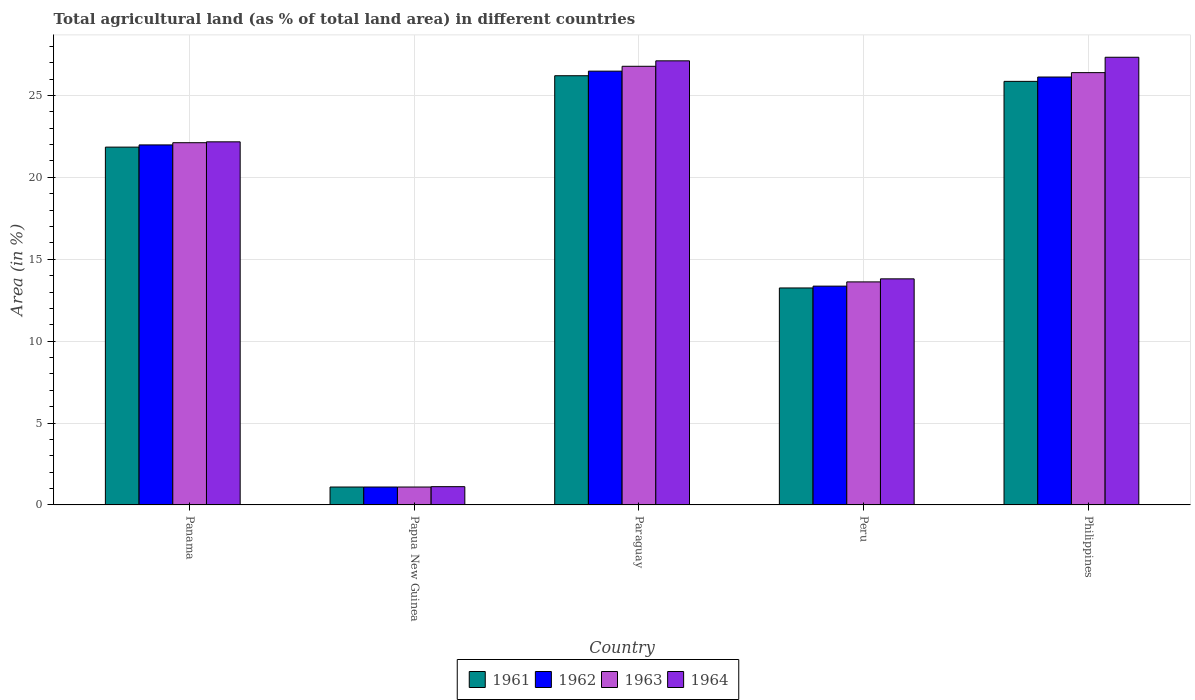How many different coloured bars are there?
Offer a terse response. 4. How many groups of bars are there?
Keep it short and to the point. 5. Are the number of bars per tick equal to the number of legend labels?
Your answer should be compact. Yes. Are the number of bars on each tick of the X-axis equal?
Offer a very short reply. Yes. How many bars are there on the 5th tick from the right?
Ensure brevity in your answer.  4. What is the label of the 5th group of bars from the left?
Your response must be concise. Philippines. In how many cases, is the number of bars for a given country not equal to the number of legend labels?
Offer a terse response. 0. What is the percentage of agricultural land in 1961 in Philippines?
Make the answer very short. 25.86. Across all countries, what is the maximum percentage of agricultural land in 1961?
Ensure brevity in your answer.  26.2. Across all countries, what is the minimum percentage of agricultural land in 1962?
Give a very brief answer. 1.09. In which country was the percentage of agricultural land in 1964 maximum?
Keep it short and to the point. Philippines. In which country was the percentage of agricultural land in 1963 minimum?
Provide a succinct answer. Papua New Guinea. What is the total percentage of agricultural land in 1962 in the graph?
Your answer should be compact. 89.04. What is the difference between the percentage of agricultural land in 1964 in Paraguay and that in Peru?
Ensure brevity in your answer.  13.31. What is the difference between the percentage of agricultural land in 1964 in Paraguay and the percentage of agricultural land in 1962 in Panama?
Your answer should be very brief. 5.13. What is the average percentage of agricultural land in 1964 per country?
Give a very brief answer. 18.31. What is the difference between the percentage of agricultural land of/in 1961 and percentage of agricultural land of/in 1963 in Peru?
Provide a short and direct response. -0.37. In how many countries, is the percentage of agricultural land in 1962 greater than 12 %?
Ensure brevity in your answer.  4. What is the ratio of the percentage of agricultural land in 1963 in Papua New Guinea to that in Paraguay?
Make the answer very short. 0.04. Is the difference between the percentage of agricultural land in 1961 in Panama and Philippines greater than the difference between the percentage of agricultural land in 1963 in Panama and Philippines?
Your answer should be compact. Yes. What is the difference between the highest and the second highest percentage of agricultural land in 1962?
Your answer should be very brief. 0.36. What is the difference between the highest and the lowest percentage of agricultural land in 1961?
Keep it short and to the point. 25.11. In how many countries, is the percentage of agricultural land in 1961 greater than the average percentage of agricultural land in 1961 taken over all countries?
Offer a terse response. 3. Is the sum of the percentage of agricultural land in 1964 in Paraguay and Peru greater than the maximum percentage of agricultural land in 1962 across all countries?
Your response must be concise. Yes. What does the 3rd bar from the left in Philippines represents?
Provide a short and direct response. 1963. What does the 3rd bar from the right in Paraguay represents?
Give a very brief answer. 1962. Are all the bars in the graph horizontal?
Your answer should be compact. No. How many countries are there in the graph?
Ensure brevity in your answer.  5. What is the difference between two consecutive major ticks on the Y-axis?
Your response must be concise. 5. Are the values on the major ticks of Y-axis written in scientific E-notation?
Your response must be concise. No. Does the graph contain any zero values?
Your answer should be very brief. No. What is the title of the graph?
Make the answer very short. Total agricultural land (as % of total land area) in different countries. What is the label or title of the X-axis?
Ensure brevity in your answer.  Country. What is the label or title of the Y-axis?
Your response must be concise. Area (in %). What is the Area (in %) in 1961 in Panama?
Your answer should be compact. 21.85. What is the Area (in %) in 1962 in Panama?
Provide a succinct answer. 21.98. What is the Area (in %) of 1963 in Panama?
Ensure brevity in your answer.  22.11. What is the Area (in %) of 1964 in Panama?
Provide a succinct answer. 22.17. What is the Area (in %) in 1961 in Papua New Guinea?
Your answer should be compact. 1.09. What is the Area (in %) of 1962 in Papua New Guinea?
Provide a succinct answer. 1.09. What is the Area (in %) in 1963 in Papua New Guinea?
Your response must be concise. 1.09. What is the Area (in %) of 1964 in Papua New Guinea?
Your answer should be compact. 1.12. What is the Area (in %) in 1961 in Paraguay?
Your answer should be very brief. 26.2. What is the Area (in %) in 1962 in Paraguay?
Your answer should be very brief. 26.48. What is the Area (in %) in 1963 in Paraguay?
Offer a terse response. 26.78. What is the Area (in %) of 1964 in Paraguay?
Provide a succinct answer. 27.11. What is the Area (in %) in 1961 in Peru?
Your response must be concise. 13.25. What is the Area (in %) in 1962 in Peru?
Keep it short and to the point. 13.36. What is the Area (in %) in 1963 in Peru?
Provide a succinct answer. 13.62. What is the Area (in %) in 1964 in Peru?
Offer a terse response. 13.8. What is the Area (in %) of 1961 in Philippines?
Your response must be concise. 25.86. What is the Area (in %) in 1962 in Philippines?
Offer a terse response. 26.12. What is the Area (in %) of 1963 in Philippines?
Provide a succinct answer. 26.39. What is the Area (in %) in 1964 in Philippines?
Keep it short and to the point. 27.33. Across all countries, what is the maximum Area (in %) of 1961?
Provide a short and direct response. 26.2. Across all countries, what is the maximum Area (in %) in 1962?
Provide a short and direct response. 26.48. Across all countries, what is the maximum Area (in %) of 1963?
Your answer should be compact. 26.78. Across all countries, what is the maximum Area (in %) in 1964?
Make the answer very short. 27.33. Across all countries, what is the minimum Area (in %) of 1961?
Provide a short and direct response. 1.09. Across all countries, what is the minimum Area (in %) of 1962?
Ensure brevity in your answer.  1.09. Across all countries, what is the minimum Area (in %) of 1963?
Ensure brevity in your answer.  1.09. Across all countries, what is the minimum Area (in %) of 1964?
Offer a very short reply. 1.12. What is the total Area (in %) in 1961 in the graph?
Your answer should be compact. 88.25. What is the total Area (in %) in 1962 in the graph?
Keep it short and to the point. 89.04. What is the total Area (in %) in 1963 in the graph?
Provide a short and direct response. 90. What is the total Area (in %) of 1964 in the graph?
Provide a succinct answer. 91.53. What is the difference between the Area (in %) in 1961 in Panama and that in Papua New Guinea?
Provide a short and direct response. 20.75. What is the difference between the Area (in %) in 1962 in Panama and that in Papua New Guinea?
Your response must be concise. 20.89. What is the difference between the Area (in %) in 1963 in Panama and that in Papua New Guinea?
Ensure brevity in your answer.  21.02. What is the difference between the Area (in %) of 1964 in Panama and that in Papua New Guinea?
Your answer should be compact. 21.05. What is the difference between the Area (in %) in 1961 in Panama and that in Paraguay?
Provide a short and direct response. -4.36. What is the difference between the Area (in %) in 1962 in Panama and that in Paraguay?
Offer a very short reply. -4.5. What is the difference between the Area (in %) in 1963 in Panama and that in Paraguay?
Provide a short and direct response. -4.67. What is the difference between the Area (in %) of 1964 in Panama and that in Paraguay?
Your response must be concise. -4.94. What is the difference between the Area (in %) in 1961 in Panama and that in Peru?
Offer a terse response. 8.6. What is the difference between the Area (in %) in 1962 in Panama and that in Peru?
Your answer should be compact. 8.62. What is the difference between the Area (in %) of 1963 in Panama and that in Peru?
Provide a succinct answer. 8.5. What is the difference between the Area (in %) of 1964 in Panama and that in Peru?
Provide a short and direct response. 8.37. What is the difference between the Area (in %) of 1961 in Panama and that in Philippines?
Provide a succinct answer. -4.01. What is the difference between the Area (in %) in 1962 in Panama and that in Philippines?
Offer a terse response. -4.14. What is the difference between the Area (in %) of 1963 in Panama and that in Philippines?
Provide a short and direct response. -4.28. What is the difference between the Area (in %) of 1964 in Panama and that in Philippines?
Provide a short and direct response. -5.16. What is the difference between the Area (in %) in 1961 in Papua New Guinea and that in Paraguay?
Your answer should be compact. -25.11. What is the difference between the Area (in %) in 1962 in Papua New Guinea and that in Paraguay?
Ensure brevity in your answer.  -25.39. What is the difference between the Area (in %) of 1963 in Papua New Guinea and that in Paraguay?
Offer a very short reply. -25.69. What is the difference between the Area (in %) of 1964 in Papua New Guinea and that in Paraguay?
Ensure brevity in your answer.  -26. What is the difference between the Area (in %) in 1961 in Papua New Guinea and that in Peru?
Provide a short and direct response. -12.15. What is the difference between the Area (in %) in 1962 in Papua New Guinea and that in Peru?
Provide a succinct answer. -12.27. What is the difference between the Area (in %) of 1963 in Papua New Guinea and that in Peru?
Make the answer very short. -12.52. What is the difference between the Area (in %) of 1964 in Papua New Guinea and that in Peru?
Offer a terse response. -12.69. What is the difference between the Area (in %) in 1961 in Papua New Guinea and that in Philippines?
Your answer should be very brief. -24.77. What is the difference between the Area (in %) in 1962 in Papua New Guinea and that in Philippines?
Provide a succinct answer. -25.03. What is the difference between the Area (in %) in 1963 in Papua New Guinea and that in Philippines?
Your answer should be very brief. -25.3. What is the difference between the Area (in %) in 1964 in Papua New Guinea and that in Philippines?
Your answer should be compact. -26.22. What is the difference between the Area (in %) in 1961 in Paraguay and that in Peru?
Your response must be concise. 12.96. What is the difference between the Area (in %) in 1962 in Paraguay and that in Peru?
Your answer should be very brief. 13.13. What is the difference between the Area (in %) of 1963 in Paraguay and that in Peru?
Offer a terse response. 13.16. What is the difference between the Area (in %) in 1964 in Paraguay and that in Peru?
Provide a short and direct response. 13.31. What is the difference between the Area (in %) in 1961 in Paraguay and that in Philippines?
Offer a very short reply. 0.34. What is the difference between the Area (in %) in 1962 in Paraguay and that in Philippines?
Offer a terse response. 0.36. What is the difference between the Area (in %) of 1963 in Paraguay and that in Philippines?
Your answer should be very brief. 0.39. What is the difference between the Area (in %) of 1964 in Paraguay and that in Philippines?
Offer a very short reply. -0.22. What is the difference between the Area (in %) of 1961 in Peru and that in Philippines?
Offer a very short reply. -12.61. What is the difference between the Area (in %) in 1962 in Peru and that in Philippines?
Offer a very short reply. -12.77. What is the difference between the Area (in %) in 1963 in Peru and that in Philippines?
Ensure brevity in your answer.  -12.78. What is the difference between the Area (in %) in 1964 in Peru and that in Philippines?
Your answer should be compact. -13.53. What is the difference between the Area (in %) of 1961 in Panama and the Area (in %) of 1962 in Papua New Guinea?
Offer a terse response. 20.75. What is the difference between the Area (in %) in 1961 in Panama and the Area (in %) in 1963 in Papua New Guinea?
Your response must be concise. 20.75. What is the difference between the Area (in %) of 1961 in Panama and the Area (in %) of 1964 in Papua New Guinea?
Offer a very short reply. 20.73. What is the difference between the Area (in %) in 1962 in Panama and the Area (in %) in 1963 in Papua New Guinea?
Make the answer very short. 20.89. What is the difference between the Area (in %) in 1962 in Panama and the Area (in %) in 1964 in Papua New Guinea?
Offer a very short reply. 20.86. What is the difference between the Area (in %) of 1963 in Panama and the Area (in %) of 1964 in Papua New Guinea?
Make the answer very short. 21. What is the difference between the Area (in %) in 1961 in Panama and the Area (in %) in 1962 in Paraguay?
Your answer should be compact. -4.64. What is the difference between the Area (in %) of 1961 in Panama and the Area (in %) of 1963 in Paraguay?
Give a very brief answer. -4.94. What is the difference between the Area (in %) in 1961 in Panama and the Area (in %) in 1964 in Paraguay?
Provide a succinct answer. -5.27. What is the difference between the Area (in %) in 1962 in Panama and the Area (in %) in 1963 in Paraguay?
Provide a short and direct response. -4.8. What is the difference between the Area (in %) in 1962 in Panama and the Area (in %) in 1964 in Paraguay?
Keep it short and to the point. -5.13. What is the difference between the Area (in %) in 1963 in Panama and the Area (in %) in 1964 in Paraguay?
Offer a terse response. -5. What is the difference between the Area (in %) of 1961 in Panama and the Area (in %) of 1962 in Peru?
Offer a terse response. 8.49. What is the difference between the Area (in %) in 1961 in Panama and the Area (in %) in 1963 in Peru?
Ensure brevity in your answer.  8.23. What is the difference between the Area (in %) in 1961 in Panama and the Area (in %) in 1964 in Peru?
Provide a succinct answer. 8.04. What is the difference between the Area (in %) in 1962 in Panama and the Area (in %) in 1963 in Peru?
Make the answer very short. 8.36. What is the difference between the Area (in %) of 1962 in Panama and the Area (in %) of 1964 in Peru?
Your answer should be compact. 8.18. What is the difference between the Area (in %) in 1963 in Panama and the Area (in %) in 1964 in Peru?
Ensure brevity in your answer.  8.31. What is the difference between the Area (in %) in 1961 in Panama and the Area (in %) in 1962 in Philippines?
Keep it short and to the point. -4.28. What is the difference between the Area (in %) of 1961 in Panama and the Area (in %) of 1963 in Philippines?
Provide a short and direct response. -4.55. What is the difference between the Area (in %) in 1961 in Panama and the Area (in %) in 1964 in Philippines?
Offer a very short reply. -5.49. What is the difference between the Area (in %) of 1962 in Panama and the Area (in %) of 1963 in Philippines?
Offer a very short reply. -4.41. What is the difference between the Area (in %) in 1962 in Panama and the Area (in %) in 1964 in Philippines?
Offer a very short reply. -5.35. What is the difference between the Area (in %) in 1963 in Panama and the Area (in %) in 1964 in Philippines?
Provide a short and direct response. -5.22. What is the difference between the Area (in %) of 1961 in Papua New Guinea and the Area (in %) of 1962 in Paraguay?
Keep it short and to the point. -25.39. What is the difference between the Area (in %) in 1961 in Papua New Guinea and the Area (in %) in 1963 in Paraguay?
Give a very brief answer. -25.69. What is the difference between the Area (in %) of 1961 in Papua New Guinea and the Area (in %) of 1964 in Paraguay?
Provide a short and direct response. -26.02. What is the difference between the Area (in %) in 1962 in Papua New Guinea and the Area (in %) in 1963 in Paraguay?
Ensure brevity in your answer.  -25.69. What is the difference between the Area (in %) in 1962 in Papua New Guinea and the Area (in %) in 1964 in Paraguay?
Your answer should be compact. -26.02. What is the difference between the Area (in %) of 1963 in Papua New Guinea and the Area (in %) of 1964 in Paraguay?
Ensure brevity in your answer.  -26.02. What is the difference between the Area (in %) in 1961 in Papua New Guinea and the Area (in %) in 1962 in Peru?
Offer a very short reply. -12.27. What is the difference between the Area (in %) of 1961 in Papua New Guinea and the Area (in %) of 1963 in Peru?
Keep it short and to the point. -12.52. What is the difference between the Area (in %) of 1961 in Papua New Guinea and the Area (in %) of 1964 in Peru?
Ensure brevity in your answer.  -12.71. What is the difference between the Area (in %) of 1962 in Papua New Guinea and the Area (in %) of 1963 in Peru?
Make the answer very short. -12.52. What is the difference between the Area (in %) in 1962 in Papua New Guinea and the Area (in %) in 1964 in Peru?
Provide a succinct answer. -12.71. What is the difference between the Area (in %) of 1963 in Papua New Guinea and the Area (in %) of 1964 in Peru?
Make the answer very short. -12.71. What is the difference between the Area (in %) of 1961 in Papua New Guinea and the Area (in %) of 1962 in Philippines?
Your response must be concise. -25.03. What is the difference between the Area (in %) of 1961 in Papua New Guinea and the Area (in %) of 1963 in Philippines?
Your response must be concise. -25.3. What is the difference between the Area (in %) in 1961 in Papua New Guinea and the Area (in %) in 1964 in Philippines?
Offer a very short reply. -26.24. What is the difference between the Area (in %) of 1962 in Papua New Guinea and the Area (in %) of 1963 in Philippines?
Offer a very short reply. -25.3. What is the difference between the Area (in %) in 1962 in Papua New Guinea and the Area (in %) in 1964 in Philippines?
Give a very brief answer. -26.24. What is the difference between the Area (in %) of 1963 in Papua New Guinea and the Area (in %) of 1964 in Philippines?
Provide a succinct answer. -26.24. What is the difference between the Area (in %) in 1961 in Paraguay and the Area (in %) in 1962 in Peru?
Your answer should be very brief. 12.85. What is the difference between the Area (in %) in 1961 in Paraguay and the Area (in %) in 1963 in Peru?
Provide a succinct answer. 12.59. What is the difference between the Area (in %) of 1961 in Paraguay and the Area (in %) of 1964 in Peru?
Provide a succinct answer. 12.4. What is the difference between the Area (in %) in 1962 in Paraguay and the Area (in %) in 1963 in Peru?
Provide a succinct answer. 12.87. What is the difference between the Area (in %) of 1962 in Paraguay and the Area (in %) of 1964 in Peru?
Offer a very short reply. 12.68. What is the difference between the Area (in %) in 1963 in Paraguay and the Area (in %) in 1964 in Peru?
Provide a short and direct response. 12.98. What is the difference between the Area (in %) of 1961 in Paraguay and the Area (in %) of 1962 in Philippines?
Your answer should be compact. 0.08. What is the difference between the Area (in %) in 1961 in Paraguay and the Area (in %) in 1963 in Philippines?
Ensure brevity in your answer.  -0.19. What is the difference between the Area (in %) in 1961 in Paraguay and the Area (in %) in 1964 in Philippines?
Your response must be concise. -1.13. What is the difference between the Area (in %) in 1962 in Paraguay and the Area (in %) in 1963 in Philippines?
Give a very brief answer. 0.09. What is the difference between the Area (in %) of 1962 in Paraguay and the Area (in %) of 1964 in Philippines?
Provide a succinct answer. -0.85. What is the difference between the Area (in %) in 1963 in Paraguay and the Area (in %) in 1964 in Philippines?
Make the answer very short. -0.55. What is the difference between the Area (in %) in 1961 in Peru and the Area (in %) in 1962 in Philippines?
Provide a short and direct response. -12.88. What is the difference between the Area (in %) of 1961 in Peru and the Area (in %) of 1963 in Philippines?
Offer a terse response. -13.15. What is the difference between the Area (in %) in 1961 in Peru and the Area (in %) in 1964 in Philippines?
Give a very brief answer. -14.09. What is the difference between the Area (in %) in 1962 in Peru and the Area (in %) in 1963 in Philippines?
Provide a short and direct response. -13.03. What is the difference between the Area (in %) of 1962 in Peru and the Area (in %) of 1964 in Philippines?
Make the answer very short. -13.97. What is the difference between the Area (in %) in 1963 in Peru and the Area (in %) in 1964 in Philippines?
Provide a succinct answer. -13.71. What is the average Area (in %) of 1961 per country?
Provide a succinct answer. 17.65. What is the average Area (in %) in 1962 per country?
Give a very brief answer. 17.81. What is the average Area (in %) in 1963 per country?
Give a very brief answer. 18. What is the average Area (in %) in 1964 per country?
Your answer should be compact. 18.31. What is the difference between the Area (in %) of 1961 and Area (in %) of 1962 in Panama?
Your response must be concise. -0.13. What is the difference between the Area (in %) of 1961 and Area (in %) of 1963 in Panama?
Offer a terse response. -0.27. What is the difference between the Area (in %) of 1961 and Area (in %) of 1964 in Panama?
Provide a short and direct response. -0.32. What is the difference between the Area (in %) in 1962 and Area (in %) in 1963 in Panama?
Provide a short and direct response. -0.13. What is the difference between the Area (in %) in 1962 and Area (in %) in 1964 in Panama?
Provide a succinct answer. -0.19. What is the difference between the Area (in %) in 1963 and Area (in %) in 1964 in Panama?
Offer a terse response. -0.05. What is the difference between the Area (in %) in 1961 and Area (in %) in 1962 in Papua New Guinea?
Give a very brief answer. 0. What is the difference between the Area (in %) of 1961 and Area (in %) of 1963 in Papua New Guinea?
Provide a succinct answer. 0. What is the difference between the Area (in %) of 1961 and Area (in %) of 1964 in Papua New Guinea?
Your answer should be very brief. -0.02. What is the difference between the Area (in %) in 1962 and Area (in %) in 1963 in Papua New Guinea?
Your answer should be very brief. 0. What is the difference between the Area (in %) in 1962 and Area (in %) in 1964 in Papua New Guinea?
Provide a succinct answer. -0.02. What is the difference between the Area (in %) of 1963 and Area (in %) of 1964 in Papua New Guinea?
Give a very brief answer. -0.02. What is the difference between the Area (in %) of 1961 and Area (in %) of 1962 in Paraguay?
Your answer should be compact. -0.28. What is the difference between the Area (in %) in 1961 and Area (in %) in 1963 in Paraguay?
Offer a terse response. -0.58. What is the difference between the Area (in %) in 1961 and Area (in %) in 1964 in Paraguay?
Your response must be concise. -0.91. What is the difference between the Area (in %) of 1962 and Area (in %) of 1963 in Paraguay?
Your response must be concise. -0.3. What is the difference between the Area (in %) in 1962 and Area (in %) in 1964 in Paraguay?
Make the answer very short. -0.63. What is the difference between the Area (in %) in 1963 and Area (in %) in 1964 in Paraguay?
Ensure brevity in your answer.  -0.33. What is the difference between the Area (in %) in 1961 and Area (in %) in 1962 in Peru?
Make the answer very short. -0.11. What is the difference between the Area (in %) of 1961 and Area (in %) of 1963 in Peru?
Keep it short and to the point. -0.37. What is the difference between the Area (in %) of 1961 and Area (in %) of 1964 in Peru?
Ensure brevity in your answer.  -0.56. What is the difference between the Area (in %) of 1962 and Area (in %) of 1963 in Peru?
Give a very brief answer. -0.26. What is the difference between the Area (in %) of 1962 and Area (in %) of 1964 in Peru?
Your answer should be very brief. -0.44. What is the difference between the Area (in %) of 1963 and Area (in %) of 1964 in Peru?
Provide a short and direct response. -0.19. What is the difference between the Area (in %) in 1961 and Area (in %) in 1962 in Philippines?
Make the answer very short. -0.26. What is the difference between the Area (in %) in 1961 and Area (in %) in 1963 in Philippines?
Your answer should be very brief. -0.53. What is the difference between the Area (in %) of 1961 and Area (in %) of 1964 in Philippines?
Provide a short and direct response. -1.47. What is the difference between the Area (in %) of 1962 and Area (in %) of 1963 in Philippines?
Your response must be concise. -0.27. What is the difference between the Area (in %) of 1962 and Area (in %) of 1964 in Philippines?
Your answer should be compact. -1.21. What is the difference between the Area (in %) in 1963 and Area (in %) in 1964 in Philippines?
Provide a short and direct response. -0.94. What is the ratio of the Area (in %) in 1961 in Panama to that in Papua New Guinea?
Ensure brevity in your answer.  19.99. What is the ratio of the Area (in %) of 1962 in Panama to that in Papua New Guinea?
Provide a short and direct response. 20.11. What is the ratio of the Area (in %) in 1963 in Panama to that in Papua New Guinea?
Your answer should be very brief. 20.23. What is the ratio of the Area (in %) of 1964 in Panama to that in Papua New Guinea?
Make the answer very short. 19.88. What is the ratio of the Area (in %) in 1961 in Panama to that in Paraguay?
Offer a very short reply. 0.83. What is the ratio of the Area (in %) in 1962 in Panama to that in Paraguay?
Make the answer very short. 0.83. What is the ratio of the Area (in %) in 1963 in Panama to that in Paraguay?
Your answer should be compact. 0.83. What is the ratio of the Area (in %) in 1964 in Panama to that in Paraguay?
Make the answer very short. 0.82. What is the ratio of the Area (in %) in 1961 in Panama to that in Peru?
Offer a terse response. 1.65. What is the ratio of the Area (in %) of 1962 in Panama to that in Peru?
Make the answer very short. 1.65. What is the ratio of the Area (in %) of 1963 in Panama to that in Peru?
Provide a succinct answer. 1.62. What is the ratio of the Area (in %) in 1964 in Panama to that in Peru?
Offer a very short reply. 1.61. What is the ratio of the Area (in %) of 1961 in Panama to that in Philippines?
Provide a short and direct response. 0.84. What is the ratio of the Area (in %) in 1962 in Panama to that in Philippines?
Your response must be concise. 0.84. What is the ratio of the Area (in %) of 1963 in Panama to that in Philippines?
Offer a very short reply. 0.84. What is the ratio of the Area (in %) of 1964 in Panama to that in Philippines?
Provide a succinct answer. 0.81. What is the ratio of the Area (in %) of 1961 in Papua New Guinea to that in Paraguay?
Give a very brief answer. 0.04. What is the ratio of the Area (in %) in 1962 in Papua New Guinea to that in Paraguay?
Your answer should be compact. 0.04. What is the ratio of the Area (in %) of 1963 in Papua New Guinea to that in Paraguay?
Your answer should be compact. 0.04. What is the ratio of the Area (in %) of 1964 in Papua New Guinea to that in Paraguay?
Provide a short and direct response. 0.04. What is the ratio of the Area (in %) in 1961 in Papua New Guinea to that in Peru?
Make the answer very short. 0.08. What is the ratio of the Area (in %) in 1962 in Papua New Guinea to that in Peru?
Ensure brevity in your answer.  0.08. What is the ratio of the Area (in %) in 1963 in Papua New Guinea to that in Peru?
Offer a terse response. 0.08. What is the ratio of the Area (in %) of 1964 in Papua New Guinea to that in Peru?
Provide a short and direct response. 0.08. What is the ratio of the Area (in %) of 1961 in Papua New Guinea to that in Philippines?
Make the answer very short. 0.04. What is the ratio of the Area (in %) in 1962 in Papua New Guinea to that in Philippines?
Give a very brief answer. 0.04. What is the ratio of the Area (in %) in 1963 in Papua New Guinea to that in Philippines?
Offer a terse response. 0.04. What is the ratio of the Area (in %) of 1964 in Papua New Guinea to that in Philippines?
Your answer should be very brief. 0.04. What is the ratio of the Area (in %) in 1961 in Paraguay to that in Peru?
Offer a terse response. 1.98. What is the ratio of the Area (in %) in 1962 in Paraguay to that in Peru?
Provide a succinct answer. 1.98. What is the ratio of the Area (in %) in 1963 in Paraguay to that in Peru?
Keep it short and to the point. 1.97. What is the ratio of the Area (in %) of 1964 in Paraguay to that in Peru?
Give a very brief answer. 1.96. What is the ratio of the Area (in %) in 1961 in Paraguay to that in Philippines?
Offer a very short reply. 1.01. What is the ratio of the Area (in %) in 1962 in Paraguay to that in Philippines?
Keep it short and to the point. 1.01. What is the ratio of the Area (in %) of 1963 in Paraguay to that in Philippines?
Provide a succinct answer. 1.01. What is the ratio of the Area (in %) of 1964 in Paraguay to that in Philippines?
Offer a very short reply. 0.99. What is the ratio of the Area (in %) in 1961 in Peru to that in Philippines?
Your answer should be very brief. 0.51. What is the ratio of the Area (in %) of 1962 in Peru to that in Philippines?
Your response must be concise. 0.51. What is the ratio of the Area (in %) in 1963 in Peru to that in Philippines?
Keep it short and to the point. 0.52. What is the ratio of the Area (in %) of 1964 in Peru to that in Philippines?
Your answer should be very brief. 0.51. What is the difference between the highest and the second highest Area (in %) in 1961?
Make the answer very short. 0.34. What is the difference between the highest and the second highest Area (in %) of 1962?
Give a very brief answer. 0.36. What is the difference between the highest and the second highest Area (in %) in 1963?
Give a very brief answer. 0.39. What is the difference between the highest and the second highest Area (in %) of 1964?
Your answer should be compact. 0.22. What is the difference between the highest and the lowest Area (in %) of 1961?
Provide a succinct answer. 25.11. What is the difference between the highest and the lowest Area (in %) in 1962?
Keep it short and to the point. 25.39. What is the difference between the highest and the lowest Area (in %) of 1963?
Offer a very short reply. 25.69. What is the difference between the highest and the lowest Area (in %) of 1964?
Offer a terse response. 26.22. 